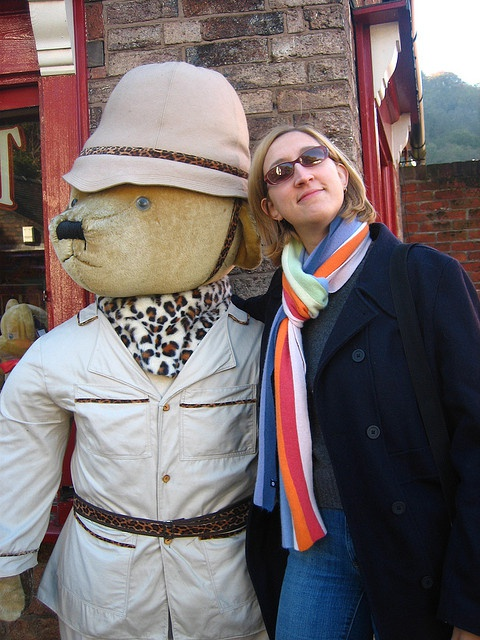Describe the objects in this image and their specific colors. I can see teddy bear in black, lightgray, darkgray, tan, and gray tones, people in black, navy, lavender, and blue tones, and teddy bear in black, olive, and gray tones in this image. 